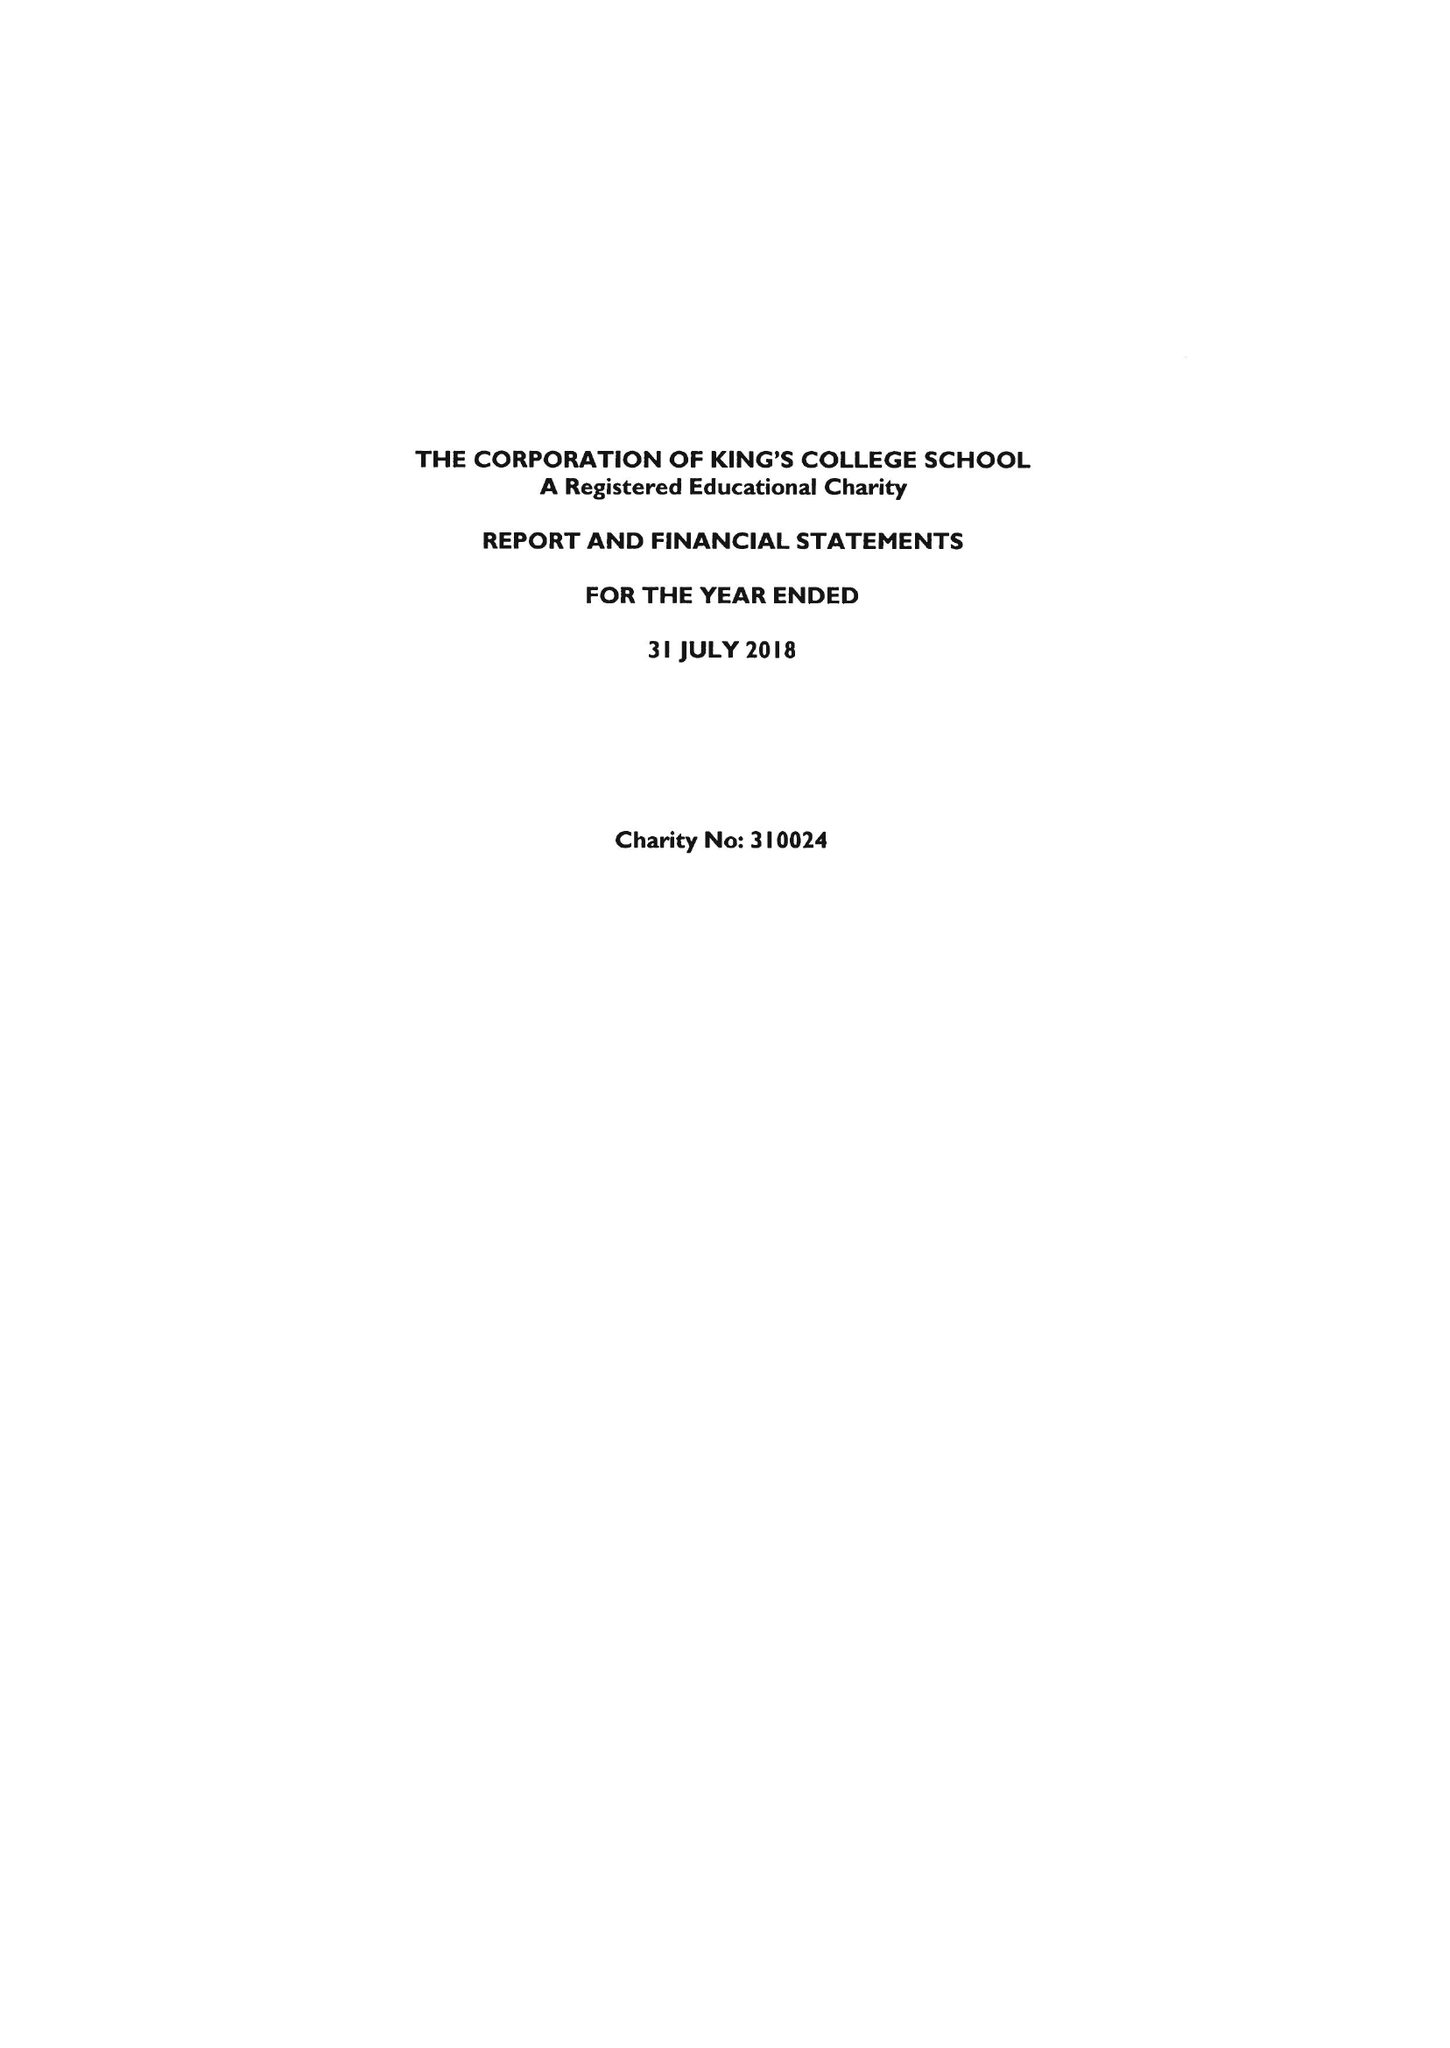What is the value for the income_annually_in_british_pounds?
Answer the question using a single word or phrase. 34077000.00 